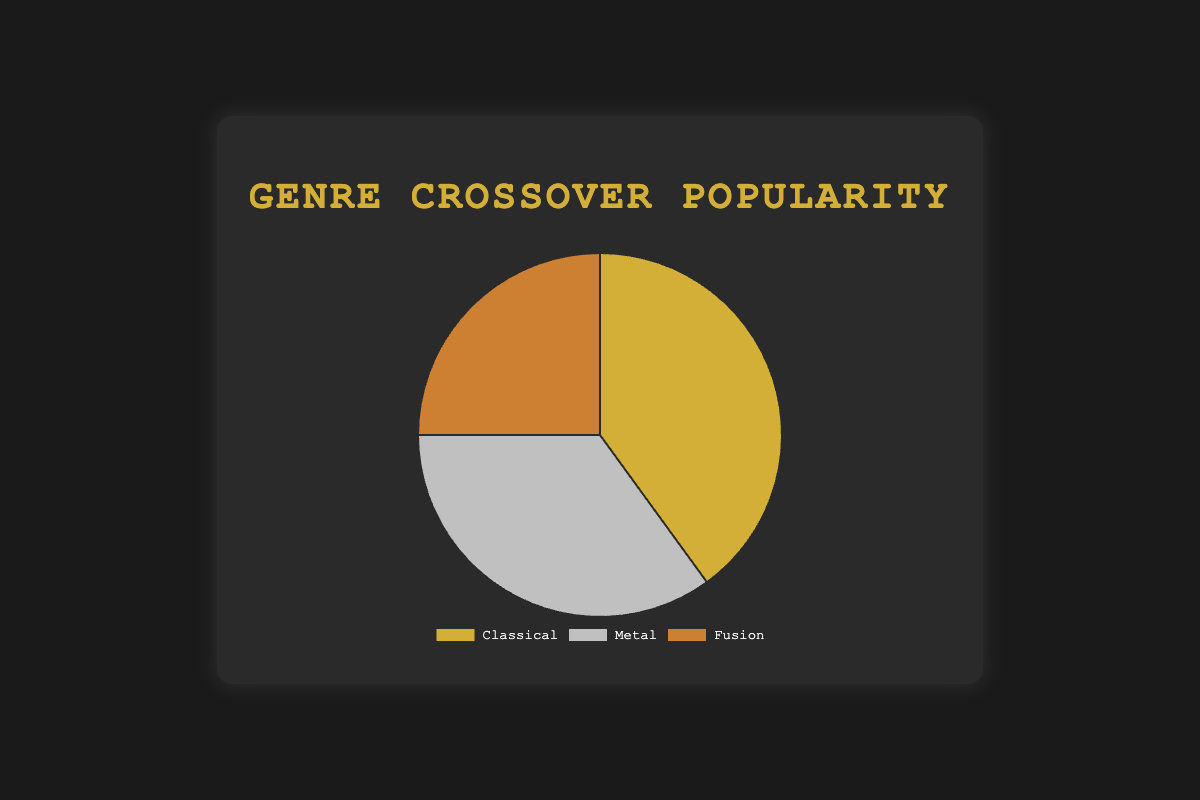What genre has the highest popularity? According to the figure, the genre with the highest percentage will have the largest section in the pie chart. Here, 40% is the highest, which belongs to Classical.
Answer: Classical Which genre is the least popular? The genre with the smallest percentage of the pie chart represents the least popular genre. Fusion has the smallest section at 25%.
Answer: Fusion What is the total percentage of the Classical and Metal genres combined? To find the combined percentage, add the individual percentages of Classical (40%) and Metal (35%) together: 40% + 35% = 75%.
Answer: 75% How much more popular is Classical compared to Fusion? To find out how much more popular Classical is compared to Fusion, subtract Fusion's percentage from Classical's: 40% - 25% = 15%.
Answer: 15% Which genre occupies the middle rank in terms of popularity? By looking at the sizes of the sections, the genre that falls between the largest and smallest sections occupies the middle rank. Here, Metal with 35% is in the middle.
Answer: Metal What is the average popularity percentage of the three genres? To calculate the average, sum up the percentages and divide by the number of genres: (40% + 35% + 25%) / 3 = 100% / 3 ≈ 33.33%.
Answer: 33.33% How many more entities are represented in Classical compared to Metal? Although the figure provides percentage data, it lists three entities for both Classical and Metal, so the difference in the number of entities is zero.
Answer: 0 What is the total percentage of genres (Classical and Metal) represented by bands? Both Classical and Metal have significant entities listed: Classical (Bach, Beethoven, Mozart) and Metal (Black Sabbath, Iron Maiden, Metallica). Add their percentages: 40% (Classical) + 35% (Metal) = 75%.
Answer: 75% Which color represents the Fusion genre? Based on the legend provided by the pie chart, each genre is associated with a specific color. Fusion is represented by bronze.
Answer: bronze 